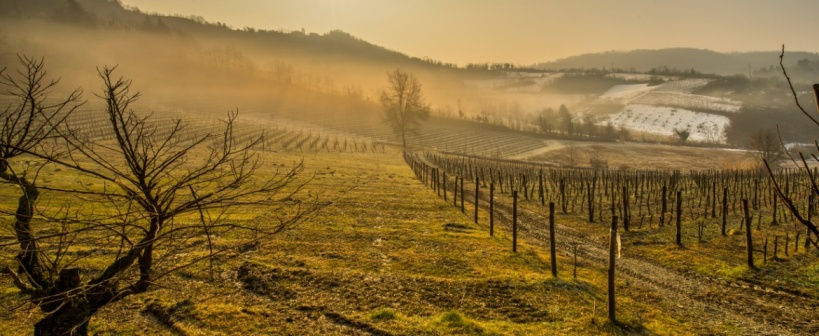What time of year do you think this image was taken and why? This image likely depicts early spring, just before the grapevines begin to bud. The bare vines, the frost on the ground, and the quality of the light, which suggests a cold, crisp morning, are all indicative of spring. Moreover, the presence of mist and a general sense of renewal in the landscape supports this timing. This period is crucial for vintners, preparing the vines for the growth season ahead and ensuring that the soil retains adequate moisture and nutrients. 